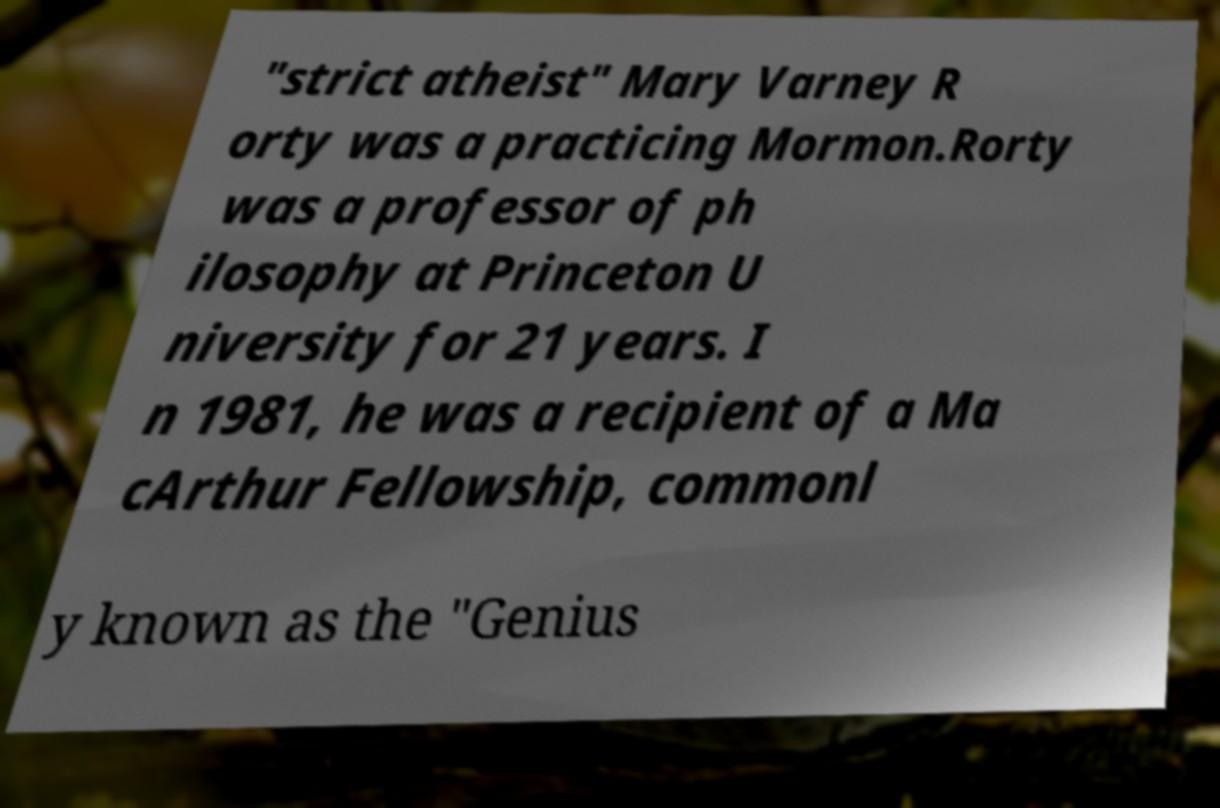Could you assist in decoding the text presented in this image and type it out clearly? "strict atheist" Mary Varney R orty was a practicing Mormon.Rorty was a professor of ph ilosophy at Princeton U niversity for 21 years. I n 1981, he was a recipient of a Ma cArthur Fellowship, commonl y known as the "Genius 